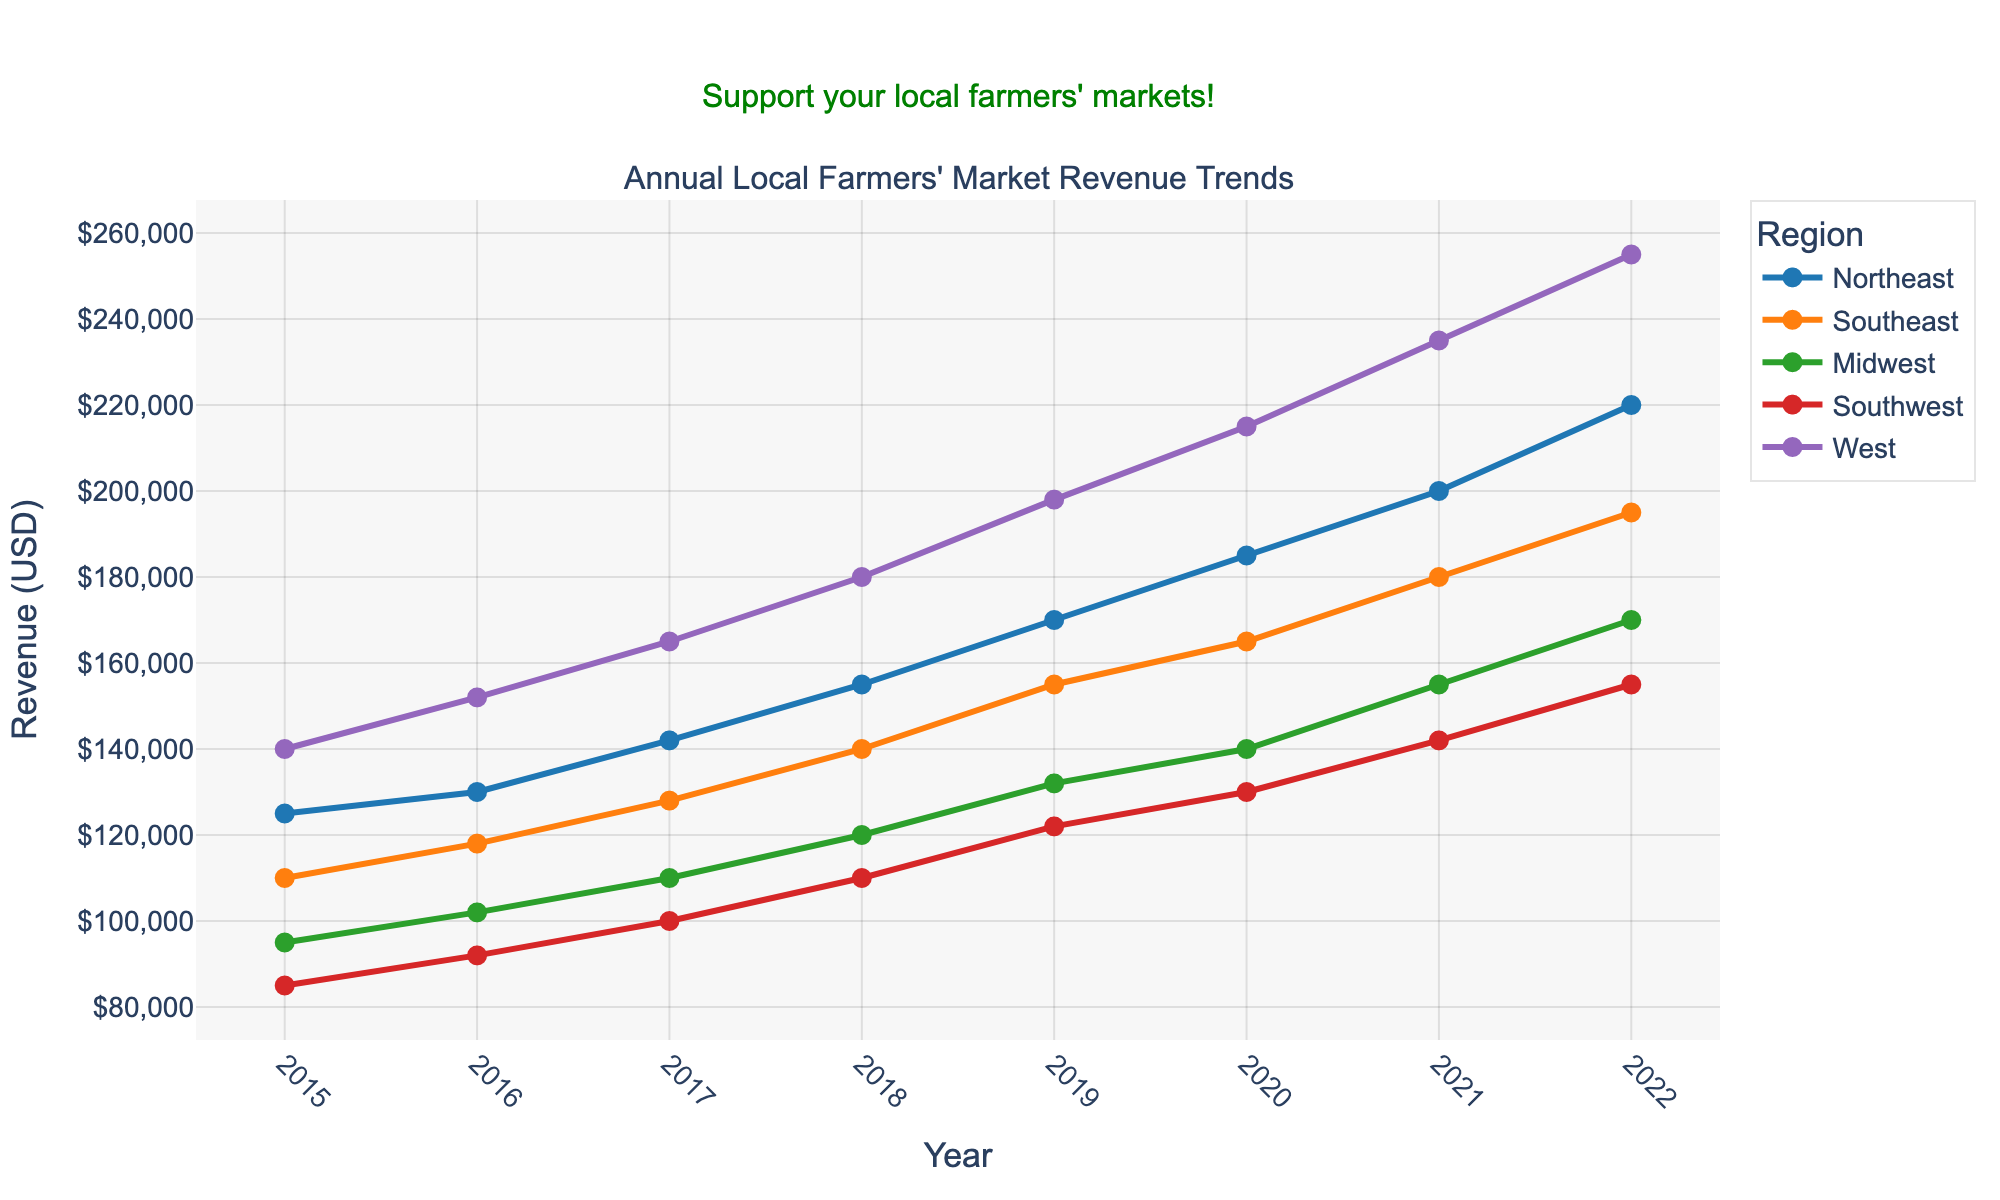What's the overall trend for the West region from 2015 to 2022? The West region shows a clear upward trend in revenue from 2015 to 2022, increasing each year. The revenue starts at $140,000 in 2015 and reaches $255,000 in 2022.
Answer: Upward Which region had the highest revenue in 2022? By examining the revenue figures for 2022, we see that the West region has the highest revenue at $255,000.
Answer: West How has the revenue for the Southeast region changed from 2015 to 2022? To determine the change, subtract the revenue in 2015 from the revenue in 2022 for the Southeast region: $195,000 (2022) - $110,000 (2015) = $85,000.
Answer: Increased by $85,000 Compare the revenue growth between the Midwest and Southwest regions from 2015 to 2022. Which region grew more? The growth in revenue for the Midwest from 2015 to 2022 is $170,000 - $95,000 = $75,000. For the Southwest, it is $155,000 - $85,000 = $70,000. Thus, the Midwest grew more.
Answer: Midwest What is the average revenue for the Northeast region over the years 2015 to 2022? Sum the yearly revenues for the Northeast region from 2015 to 2022 and divide by the number of years: (125,000 + 130,000 + 142,000 + 155,000 + 170,000 + 185,000 + 200,000 + 220,000) / 8 = $165,875.
Answer: $165,875 Which region showed the smallest increase in revenue from 2015 to 2022? Calculate the increase for each region and compare them. The Southwest region had the smallest increase, with $70,000 ($155,000 - $85,000).
Answer: Southwest How did the revenue for the Northeast region compare to the West region in 2020? The revenue for the Northeast region in 2020 was $185,000, while for the West it was $215,000. Thus, the West region had a higher revenue.
Answer: West If you rank the regions by their revenue in 2019, what is the order from highest to lowest? The revenues in 2019 are: West ($198,000), Northeast ($170,000), Southeast ($155,000), Midwest ($132,000), Southwest ($122,000). The order from highest to lowest is: West, Northeast, Southeast, Midwest, Southwest.
Answer: West, Northeast, Southeast, Midwest, Southwest What is the median revenue for the Midwest region from 2015 to 2022? First, arrange the revenues in order and find the middle values: $95,000, $102,000, $110,000, $120,000, $132,000, $140,000, $155,000, $170,000. The median is the average of the 4th and 5th values: ($120,000 + $132,000) / 2 = $126,000.
Answer: $126,000 